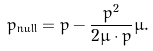Convert formula to latex. <formula><loc_0><loc_0><loc_500><loc_500>p _ { \text {null} } = p - \frac { p ^ { 2 } } { 2 \mu \cdot p } \mu .</formula> 